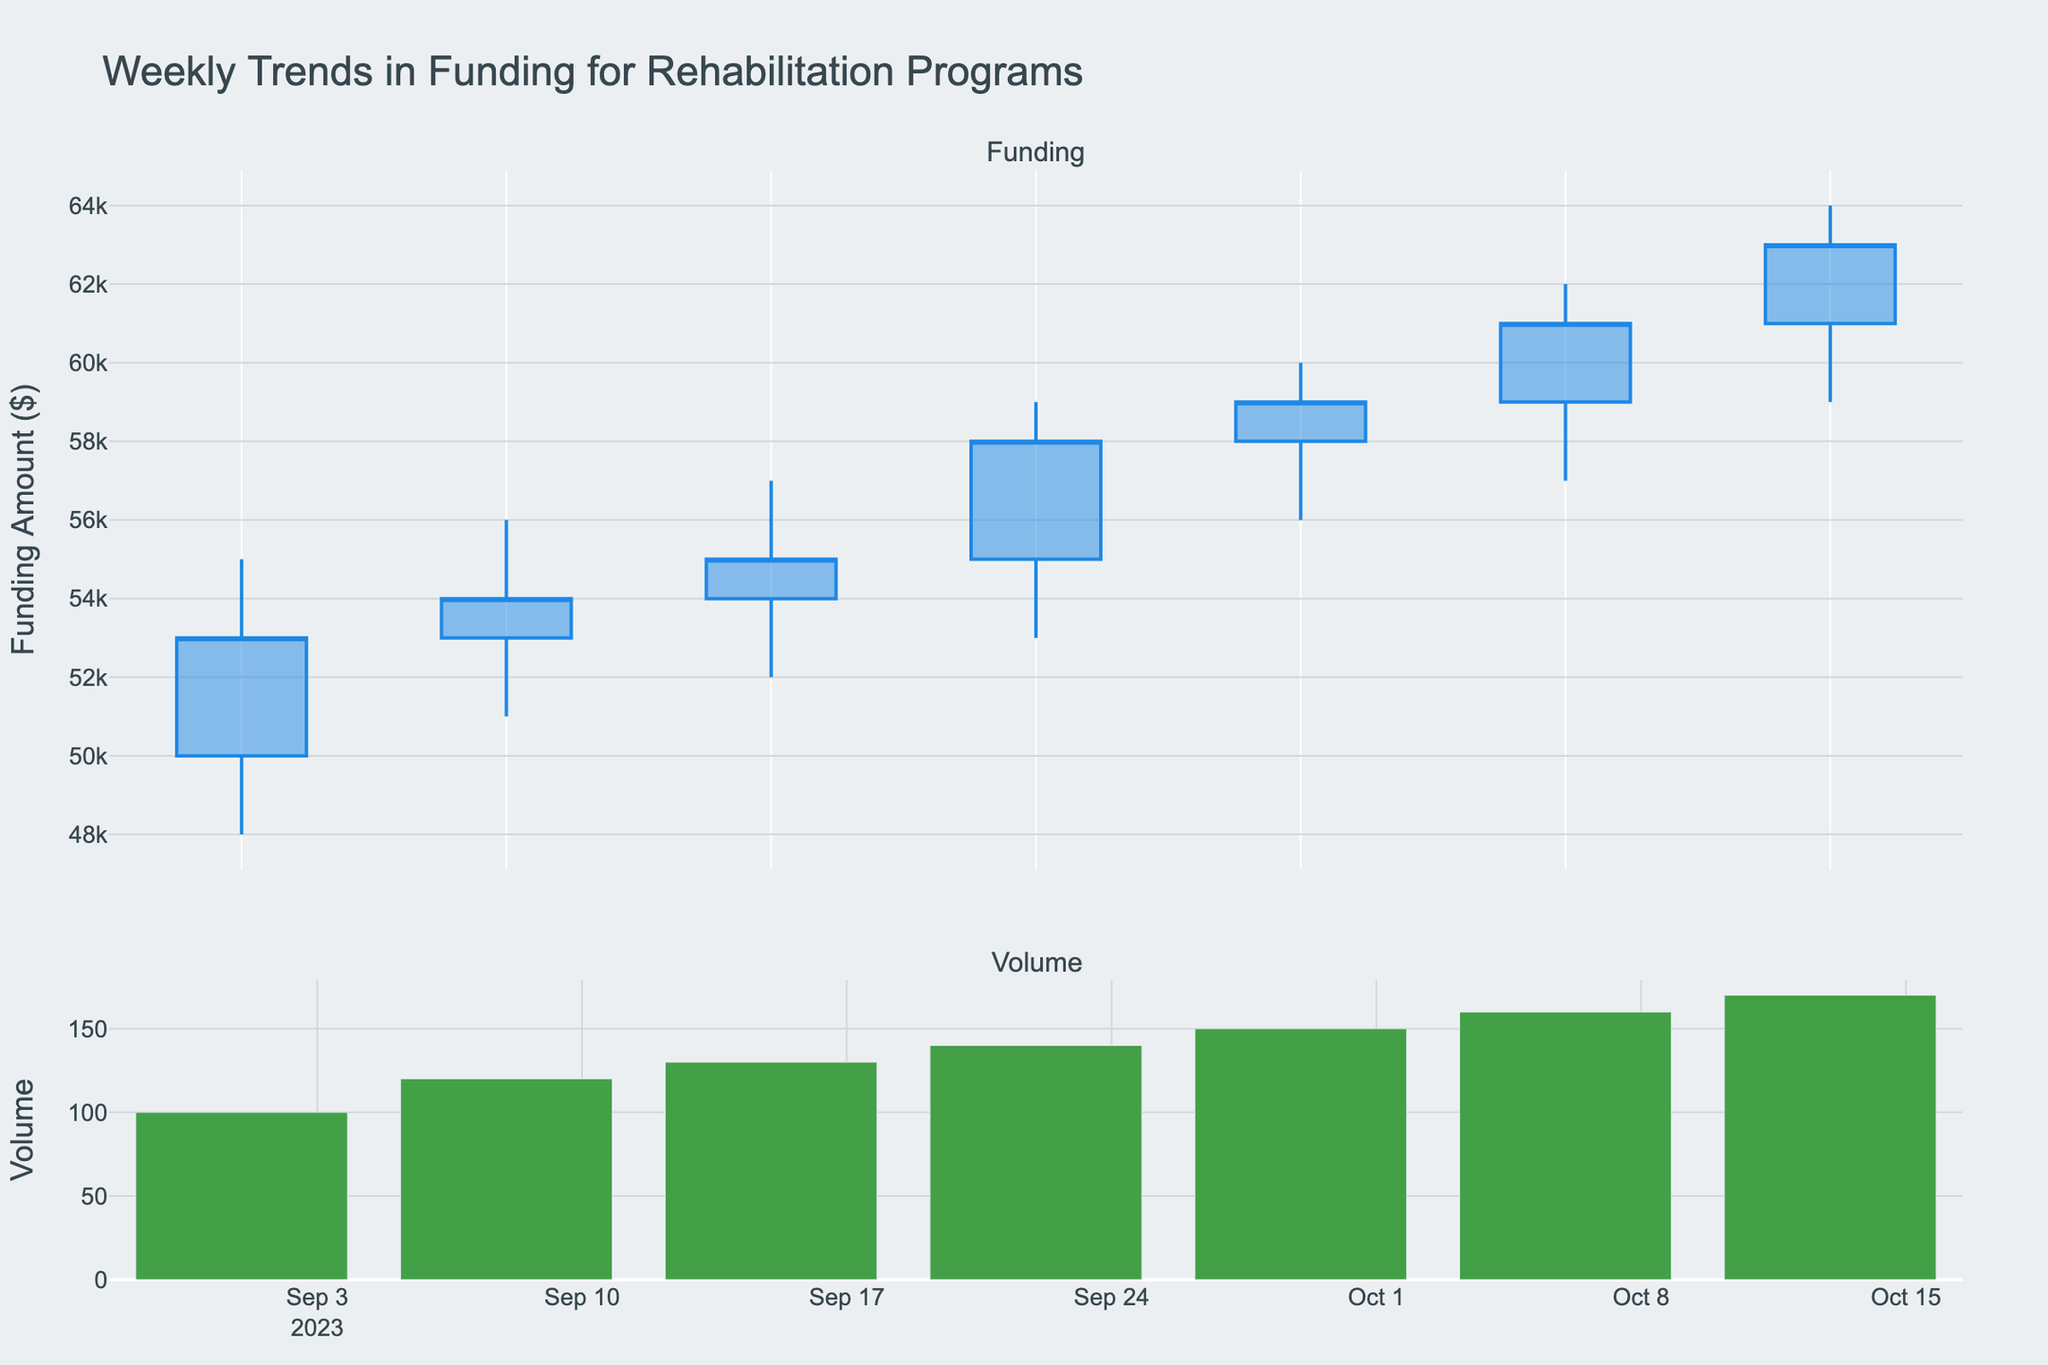what is the title of the figure? The title can be found at the top of the figure. It provides a summary of what the figure is about.
Answer: Weekly Trends in Funding for Rehabilitation Programs What is the highest funding amount recorded in September 2023? Look at the 'High' values for all the candlesticks in September and find the maximum.
Answer: $59,000 Which week had the lowest funding amount in October 2023? Look at the 'Low' values for each week in October and identify the minimum.
Answer: October 6, 2023 What is the average closing funding amount in the data set? Sum all the 'Close' values and divide by the number of data points. (53,000 + 54,000 + 55,000 + 58,000 + 59,000 + 61,000 + 63,000) / 7 = 57,571.43
Answer: $57,571.43 Did any week in the dataset have decreasing funding from open to close? Look for candlesticks where the 'Close' value is lower than the 'Open' value.
Answer: Yes, one week (September 1, 2023) How did the funding trend change between September 22, 2023, and October 13, 2023? Compare the 'Close' values for both dates. September 22, 2023, had a 'Close' of $58,000, and October 13, 2023, had a 'Close' of $63,000.
Answer: Increased by $5,000 Which week had the highest trading volume, and what was it? Look at the 'Volume' values for all weeks and identify the maximum. October 13, 2023, had a volume of 170.
Answer: October 13, 2023; 170 Calculate the average volume for the entire period. Sum all the 'Volume' values and divide by the number of data points. (100 + 120 + 130 + 140 + 150 + 160 + 170) / 7 = 138.57
Answer: 138.57 Between which two consecutive weeks did the funding show the highest increase in closing values? Subtract 'Close' of each week from the 'Close' of the next week and identify the maximum increase. 
September 22, 2023, to September 29, 2023, saw an increase from $58,000 to $59,000, which is $3,000.
Answer: September 29, 2023, to October 6, 2023 What was the highest funding amount recorded in October 2023? Look at the 'High' values for all the candlesticks in October and find the maximum.
Answer: $64,000 